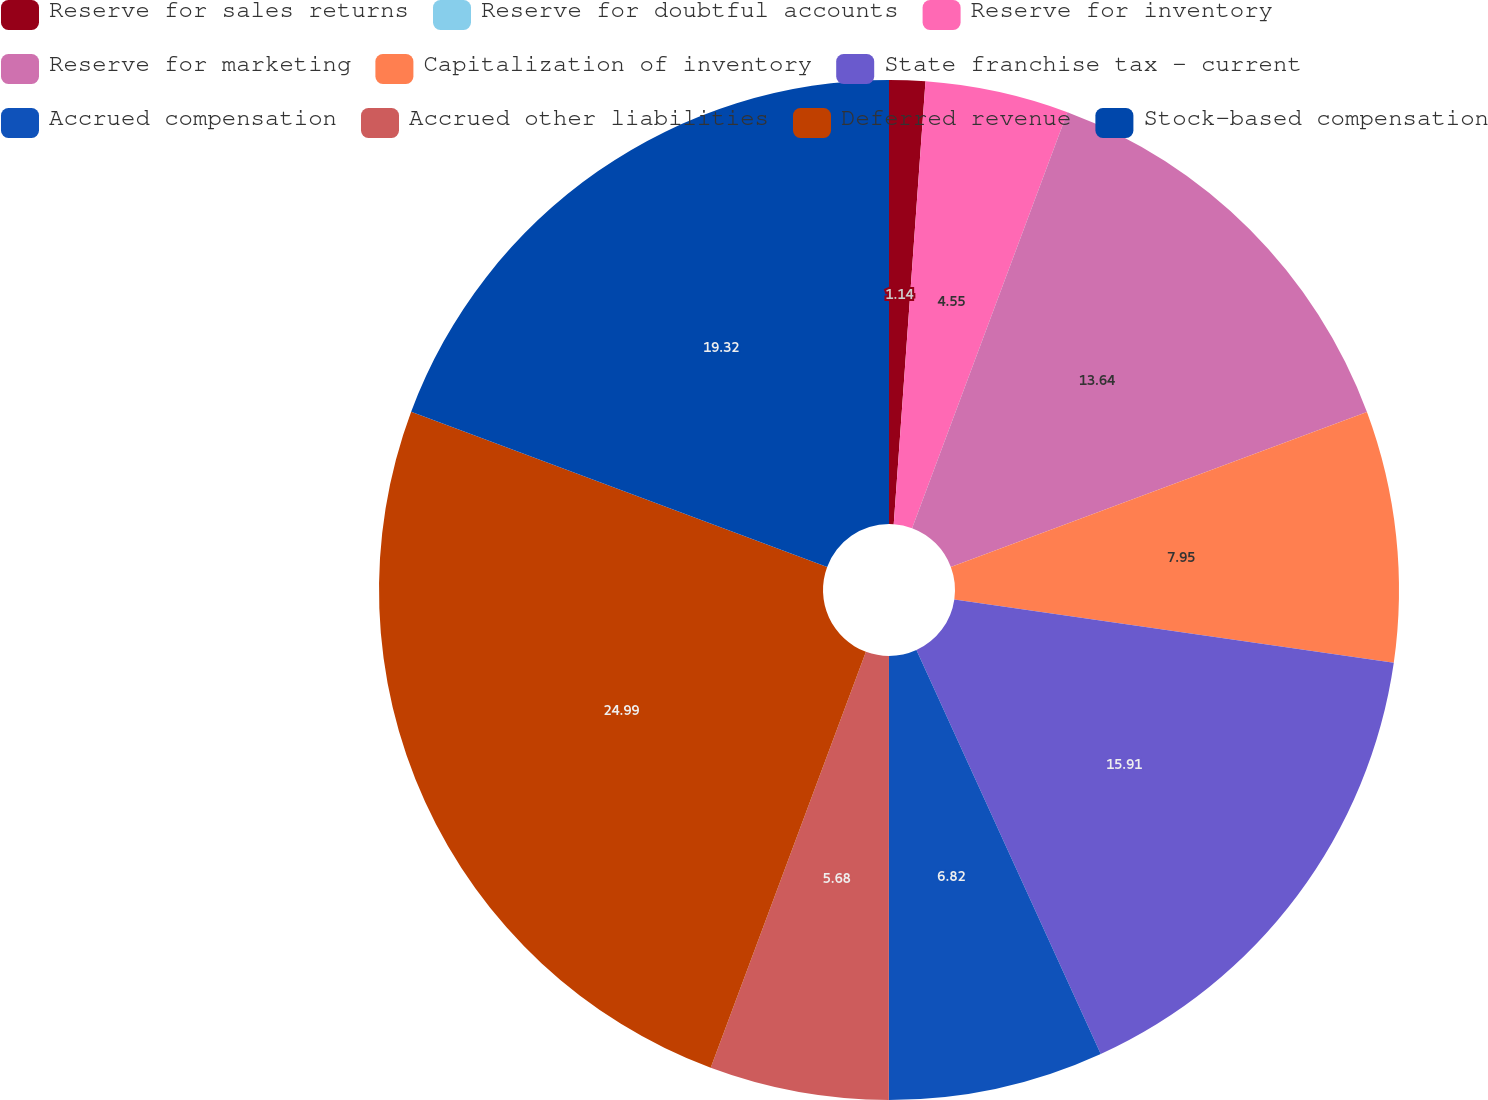Convert chart. <chart><loc_0><loc_0><loc_500><loc_500><pie_chart><fcel>Reserve for sales returns<fcel>Reserve for doubtful accounts<fcel>Reserve for inventory<fcel>Reserve for marketing<fcel>Capitalization of inventory<fcel>State franchise tax - current<fcel>Accrued compensation<fcel>Accrued other liabilities<fcel>Deferred revenue<fcel>Stock-based compensation<nl><fcel>1.14%<fcel>0.0%<fcel>4.55%<fcel>13.64%<fcel>7.95%<fcel>15.91%<fcel>6.82%<fcel>5.68%<fcel>25.0%<fcel>19.32%<nl></chart> 